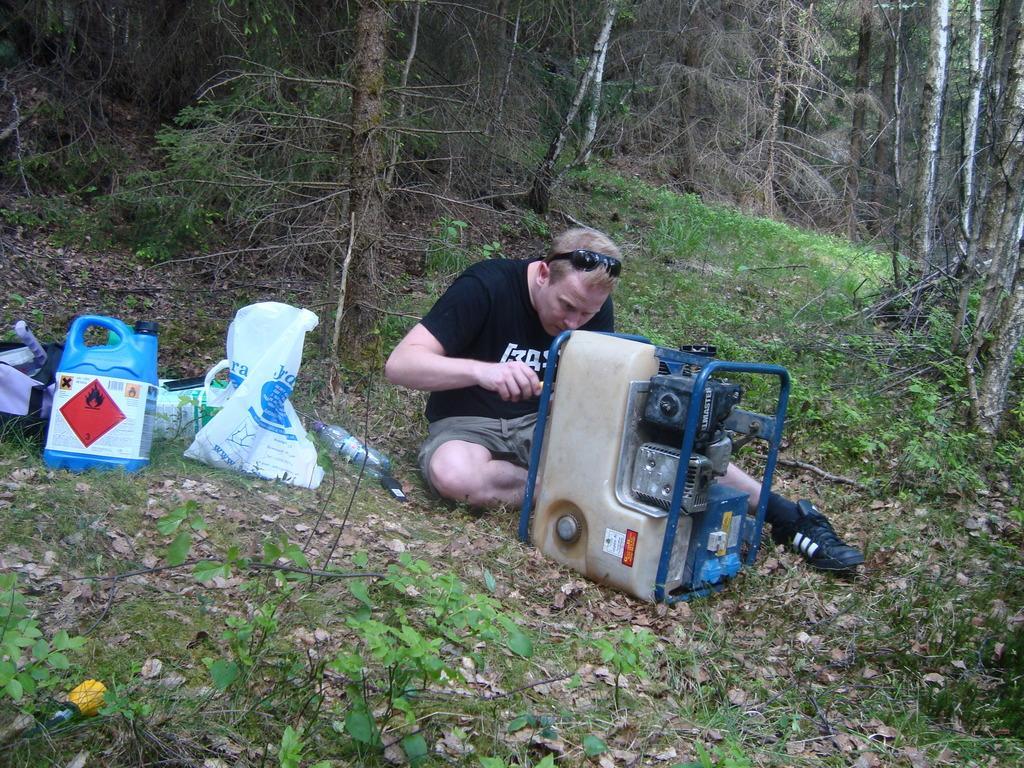Describe this image in one or two sentences. In this picture we can see a man sitting and repairing a device. We can see a cover, bottle, bag and a can on the path. There are some plants and few tree trunks in the background. 